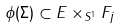<formula> <loc_0><loc_0><loc_500><loc_500>\phi ( \Sigma ) \subset E \times _ { S ^ { 1 } } F _ { j }</formula> 